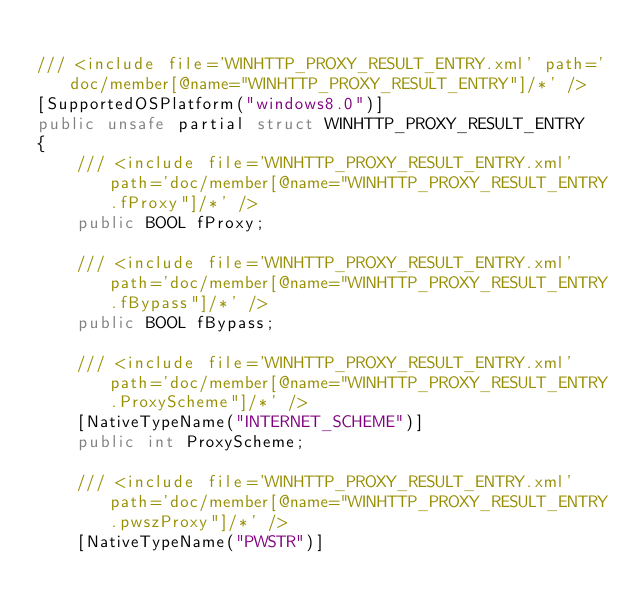Convert code to text. <code><loc_0><loc_0><loc_500><loc_500><_C#_>
/// <include file='WINHTTP_PROXY_RESULT_ENTRY.xml' path='doc/member[@name="WINHTTP_PROXY_RESULT_ENTRY"]/*' />
[SupportedOSPlatform("windows8.0")]
public unsafe partial struct WINHTTP_PROXY_RESULT_ENTRY
{
    /// <include file='WINHTTP_PROXY_RESULT_ENTRY.xml' path='doc/member[@name="WINHTTP_PROXY_RESULT_ENTRY.fProxy"]/*' />
    public BOOL fProxy;

    /// <include file='WINHTTP_PROXY_RESULT_ENTRY.xml' path='doc/member[@name="WINHTTP_PROXY_RESULT_ENTRY.fBypass"]/*' />
    public BOOL fBypass;

    /// <include file='WINHTTP_PROXY_RESULT_ENTRY.xml' path='doc/member[@name="WINHTTP_PROXY_RESULT_ENTRY.ProxyScheme"]/*' />
    [NativeTypeName("INTERNET_SCHEME")]
    public int ProxyScheme;

    /// <include file='WINHTTP_PROXY_RESULT_ENTRY.xml' path='doc/member[@name="WINHTTP_PROXY_RESULT_ENTRY.pwszProxy"]/*' />
    [NativeTypeName("PWSTR")]</code> 